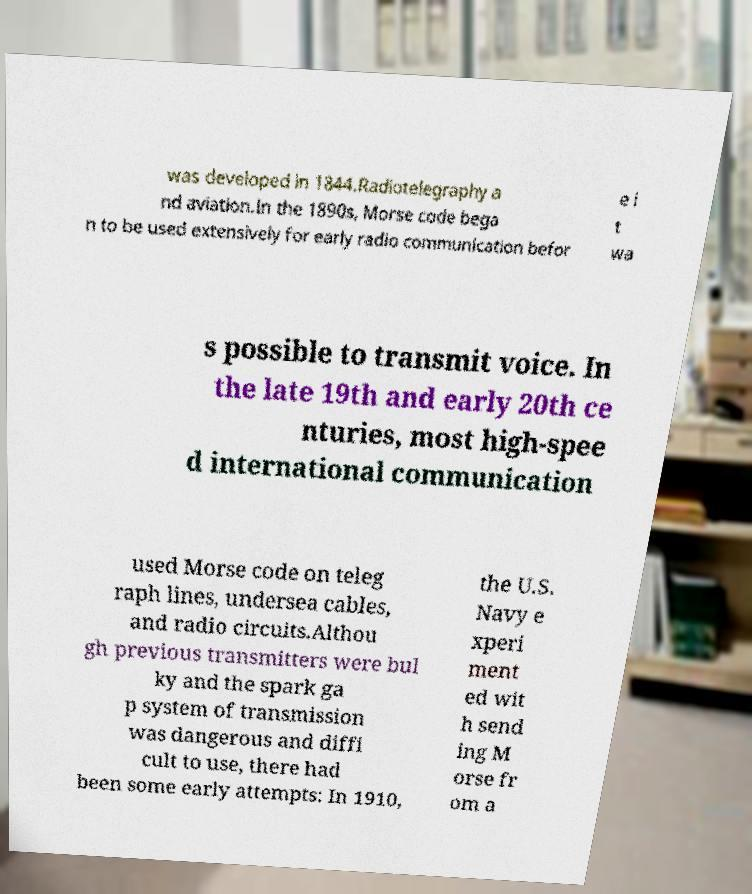Can you accurately transcribe the text from the provided image for me? was developed in 1844.Radiotelegraphy a nd aviation.In the 1890s, Morse code bega n to be used extensively for early radio communication befor e i t wa s possible to transmit voice. In the late 19th and early 20th ce nturies, most high-spee d international communication used Morse code on teleg raph lines, undersea cables, and radio circuits.Althou gh previous transmitters were bul ky and the spark ga p system of transmission was dangerous and diffi cult to use, there had been some early attempts: In 1910, the U.S. Navy e xperi ment ed wit h send ing M orse fr om a 